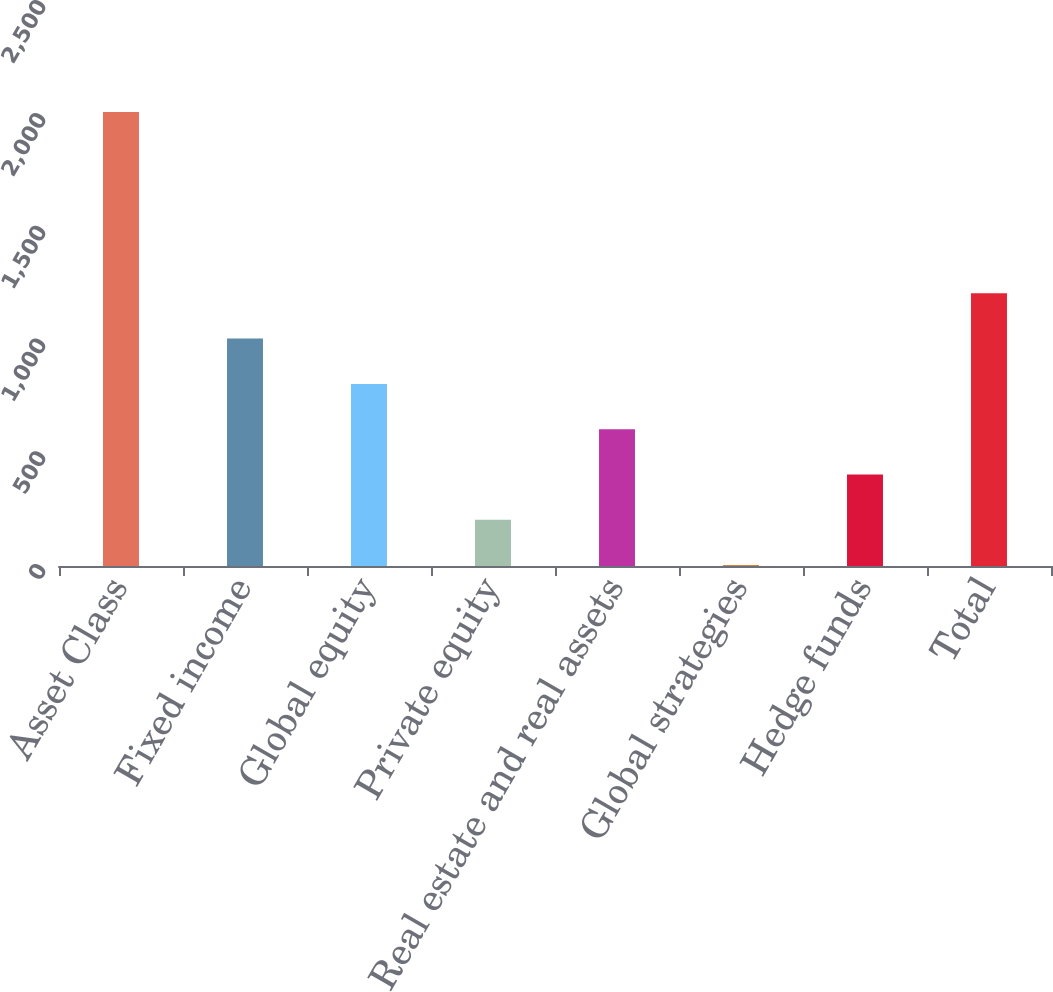<chart> <loc_0><loc_0><loc_500><loc_500><bar_chart><fcel>Asset Class<fcel>Fixed income<fcel>Global equity<fcel>Private equity<fcel>Real estate and real assets<fcel>Global strategies<fcel>Hedge funds<fcel>Total<nl><fcel>2012<fcel>1008<fcel>807.2<fcel>204.8<fcel>606.4<fcel>4<fcel>405.6<fcel>1208.8<nl></chart> 